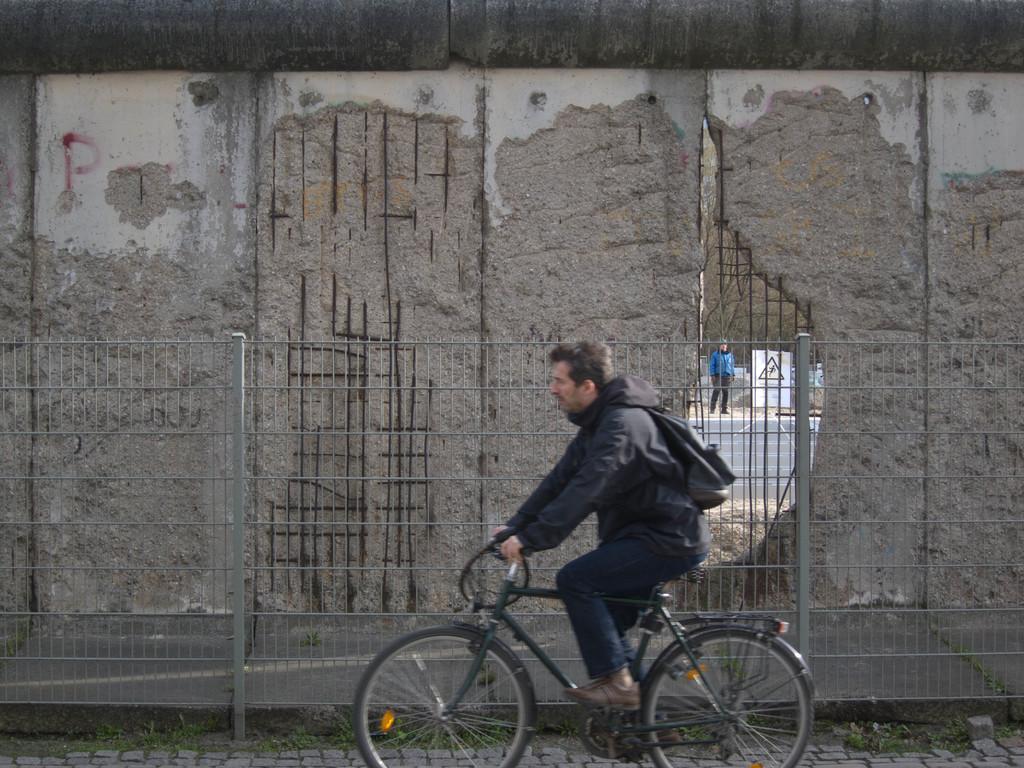Please provide a concise description of this image. In the image there is a man riding a bicycle, in background there are fence,wall and a man standing. 